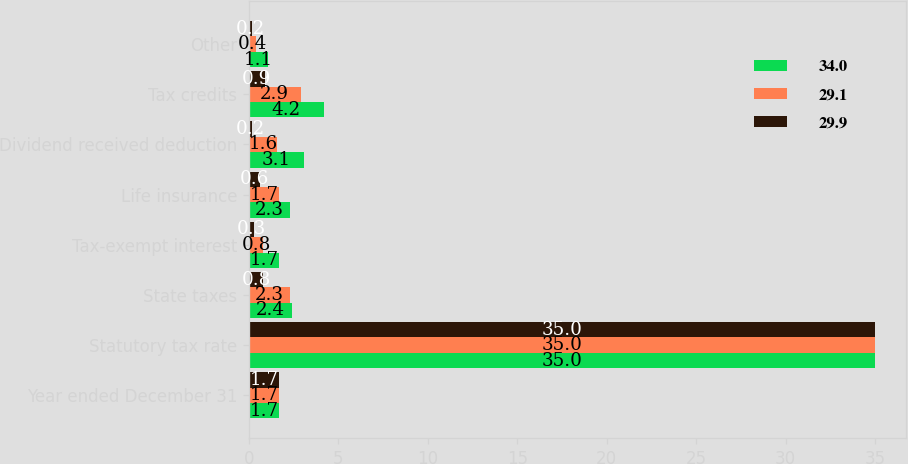<chart> <loc_0><loc_0><loc_500><loc_500><stacked_bar_chart><ecel><fcel>Year ended December 31<fcel>Statutory tax rate<fcel>State taxes<fcel>Tax-exempt interest<fcel>Life insurance<fcel>Dividend received deduction<fcel>Tax credits<fcel>Other<nl><fcel>34<fcel>1.7<fcel>35<fcel>2.4<fcel>1.7<fcel>2.3<fcel>3.1<fcel>4.2<fcel>1.1<nl><fcel>29.1<fcel>1.7<fcel>35<fcel>2.3<fcel>0.8<fcel>1.7<fcel>1.6<fcel>2.9<fcel>0.4<nl><fcel>29.9<fcel>1.7<fcel>35<fcel>0.8<fcel>0.3<fcel>0.6<fcel>0.2<fcel>0.9<fcel>0.2<nl></chart> 